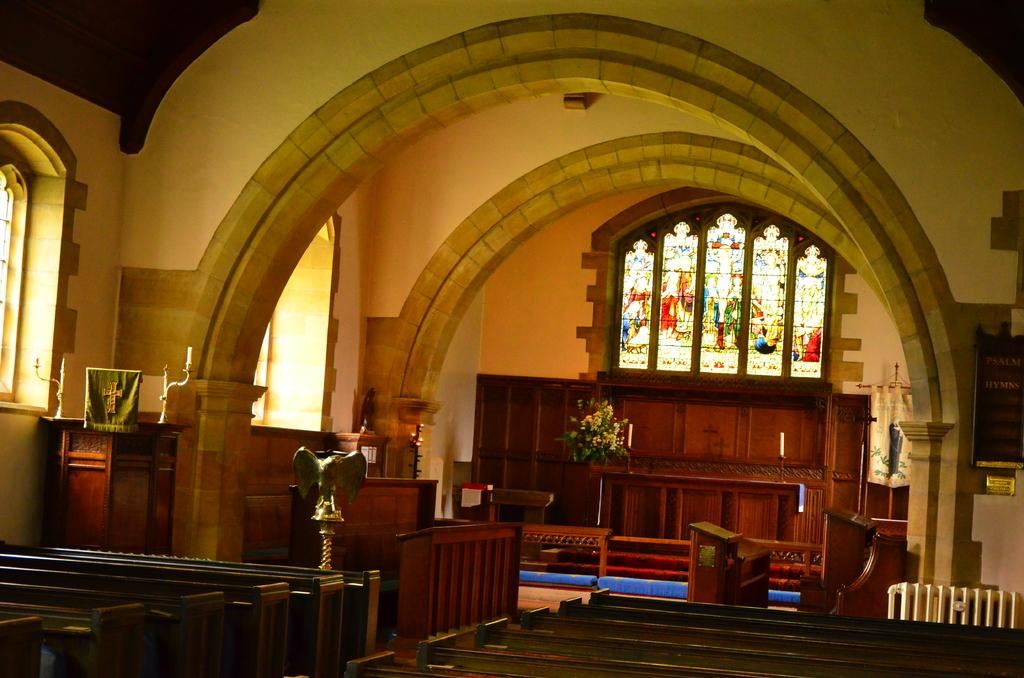What type of location is depicted in the image? The image is an inside view of a building. What type of furniture is present in the image? There are benches in the image. Are there any plants visible in the image? Yes, there is a plant in the image. What other objects can be seen in the image? There is a table, a frame, and cupboards in the image. What architectural features are present in the image? There are windows and a wall in the image. In which direction is the hen facing in the image? There is no hen present in the image. Can you provide an example of a similar building to the one depicted in the image? The image does not provide enough information to compare it to other buildings, as it only shows a specific room or area within the building. 